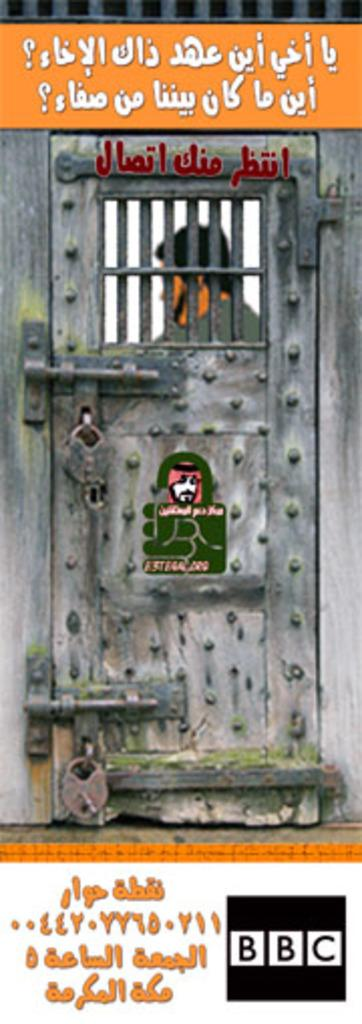What is the main subject in the center of the image? There is a door in the center of the image. What is the status of the door? The door is locked. Can you describe the situation of the person in relation to the door? There is a person inside the door. What is the rate at which the person is trying to open the locked door in the image? There is no information about the rate at which the person is trying to open the door in the image. 